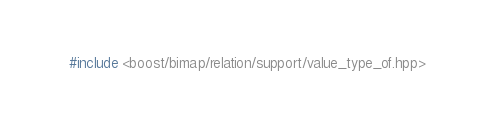Convert code to text. <code><loc_0><loc_0><loc_500><loc_500><_C++_>#include <boost/bimap/relation/support/value_type_of.hpp>
</code> 